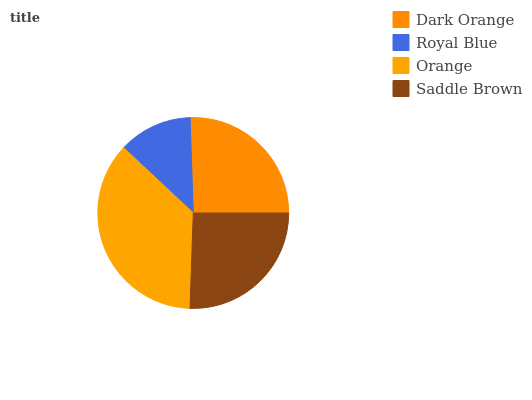Is Royal Blue the minimum?
Answer yes or no. Yes. Is Orange the maximum?
Answer yes or no. Yes. Is Orange the minimum?
Answer yes or no. No. Is Royal Blue the maximum?
Answer yes or no. No. Is Orange greater than Royal Blue?
Answer yes or no. Yes. Is Royal Blue less than Orange?
Answer yes or no. Yes. Is Royal Blue greater than Orange?
Answer yes or no. No. Is Orange less than Royal Blue?
Answer yes or no. No. Is Saddle Brown the high median?
Answer yes or no. Yes. Is Dark Orange the low median?
Answer yes or no. Yes. Is Orange the high median?
Answer yes or no. No. Is Royal Blue the low median?
Answer yes or no. No. 